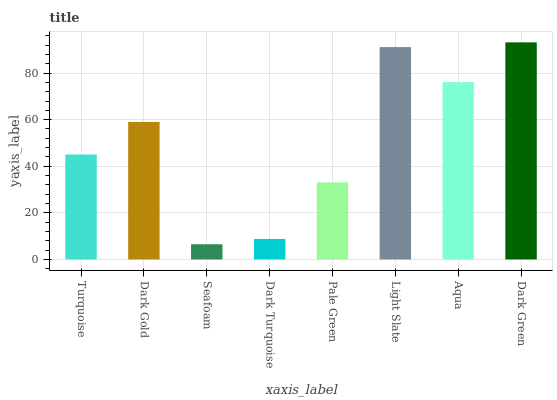Is Seafoam the minimum?
Answer yes or no. Yes. Is Dark Green the maximum?
Answer yes or no. Yes. Is Dark Gold the minimum?
Answer yes or no. No. Is Dark Gold the maximum?
Answer yes or no. No. Is Dark Gold greater than Turquoise?
Answer yes or no. Yes. Is Turquoise less than Dark Gold?
Answer yes or no. Yes. Is Turquoise greater than Dark Gold?
Answer yes or no. No. Is Dark Gold less than Turquoise?
Answer yes or no. No. Is Dark Gold the high median?
Answer yes or no. Yes. Is Turquoise the low median?
Answer yes or no. Yes. Is Pale Green the high median?
Answer yes or no. No. Is Aqua the low median?
Answer yes or no. No. 